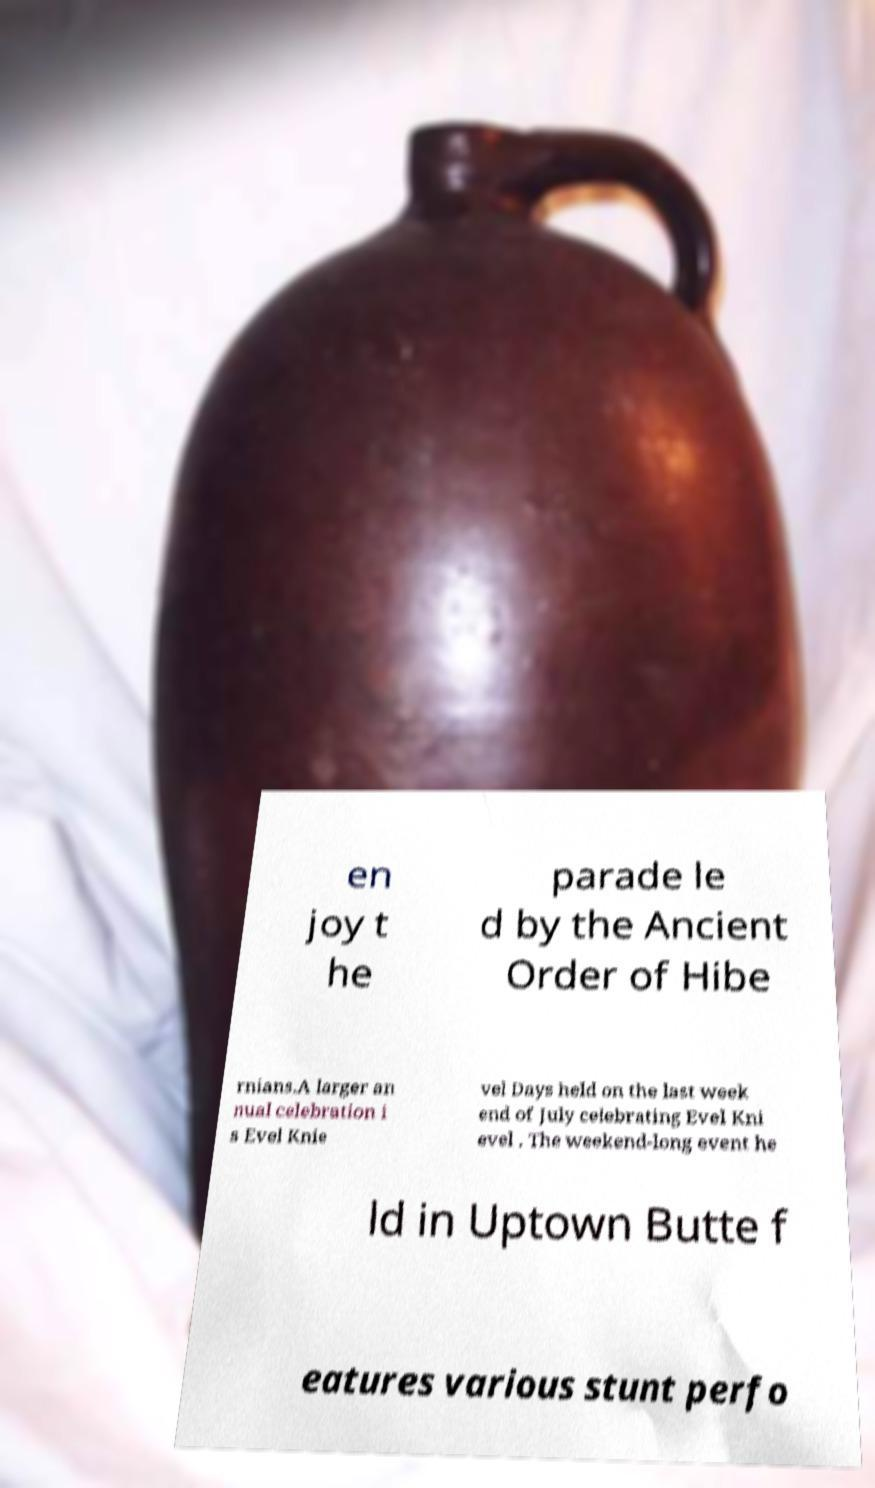Can you read and provide the text displayed in the image?This photo seems to have some interesting text. Can you extract and type it out for me? en joy t he parade le d by the Ancient Order of Hibe rnians.A larger an nual celebration i s Evel Knie vel Days held on the last week end of July celebrating Evel Kni evel . The weekend-long event he ld in Uptown Butte f eatures various stunt perfo 